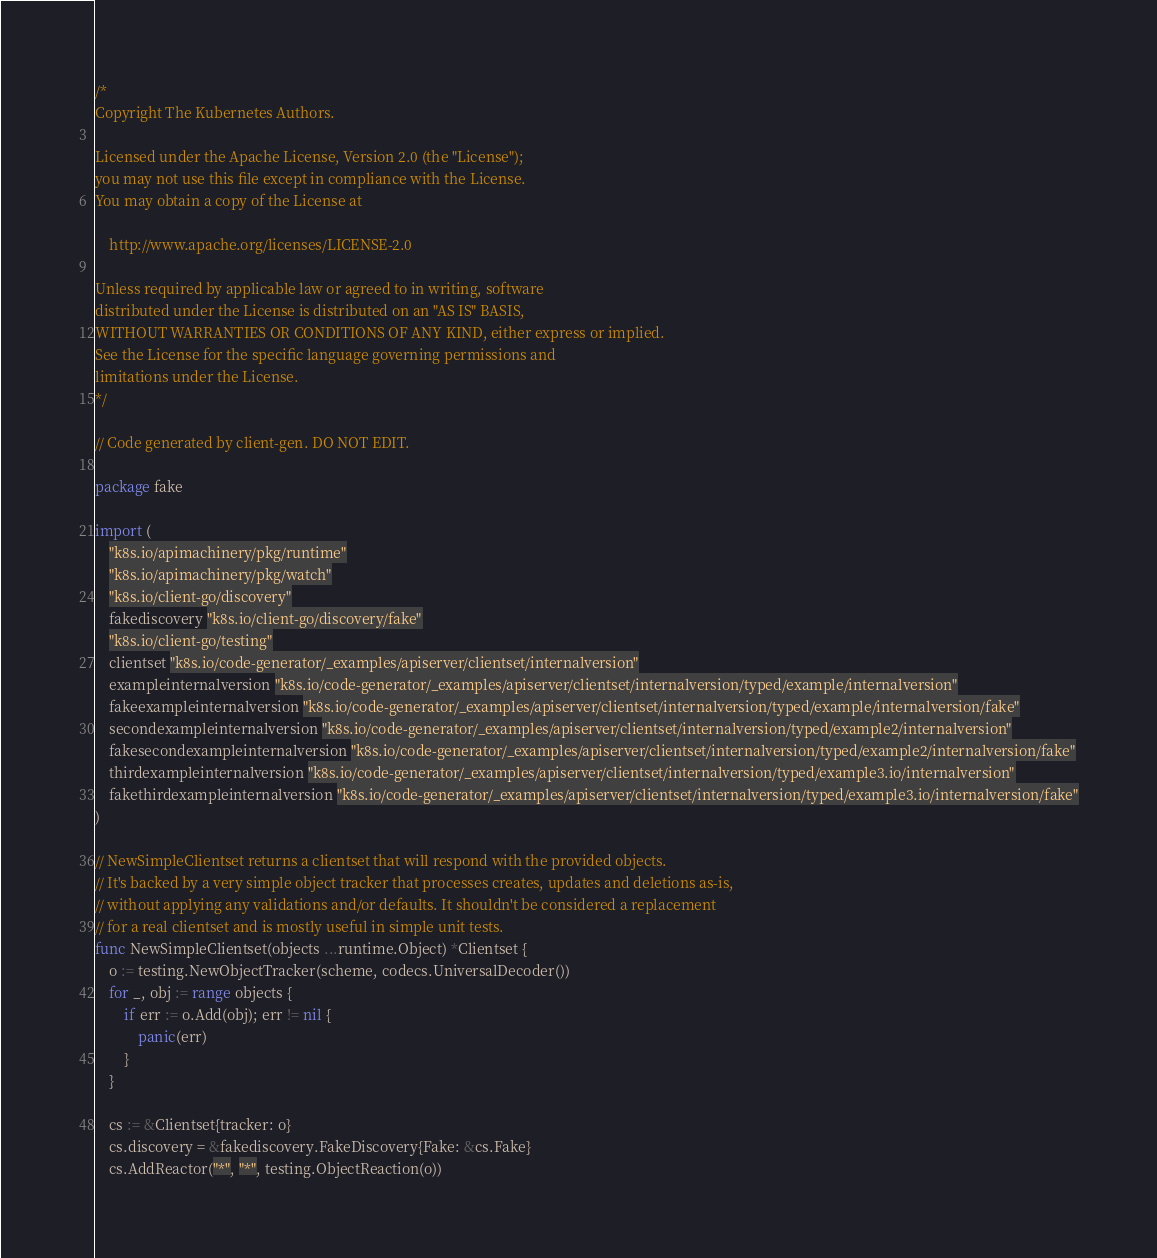Convert code to text. <code><loc_0><loc_0><loc_500><loc_500><_Go_>/*
Copyright The Kubernetes Authors.

Licensed under the Apache License, Version 2.0 (the "License");
you may not use this file except in compliance with the License.
You may obtain a copy of the License at

    http://www.apache.org/licenses/LICENSE-2.0

Unless required by applicable law or agreed to in writing, software
distributed under the License is distributed on an "AS IS" BASIS,
WITHOUT WARRANTIES OR CONDITIONS OF ANY KIND, either express or implied.
See the License for the specific language governing permissions and
limitations under the License.
*/

// Code generated by client-gen. DO NOT EDIT.

package fake

import (
	"k8s.io/apimachinery/pkg/runtime"
	"k8s.io/apimachinery/pkg/watch"
	"k8s.io/client-go/discovery"
	fakediscovery "k8s.io/client-go/discovery/fake"
	"k8s.io/client-go/testing"
	clientset "k8s.io/code-generator/_examples/apiserver/clientset/internalversion"
	exampleinternalversion "k8s.io/code-generator/_examples/apiserver/clientset/internalversion/typed/example/internalversion"
	fakeexampleinternalversion "k8s.io/code-generator/_examples/apiserver/clientset/internalversion/typed/example/internalversion/fake"
	secondexampleinternalversion "k8s.io/code-generator/_examples/apiserver/clientset/internalversion/typed/example2/internalversion"
	fakesecondexampleinternalversion "k8s.io/code-generator/_examples/apiserver/clientset/internalversion/typed/example2/internalversion/fake"
	thirdexampleinternalversion "k8s.io/code-generator/_examples/apiserver/clientset/internalversion/typed/example3.io/internalversion"
	fakethirdexampleinternalversion "k8s.io/code-generator/_examples/apiserver/clientset/internalversion/typed/example3.io/internalversion/fake"
)

// NewSimpleClientset returns a clientset that will respond with the provided objects.
// It's backed by a very simple object tracker that processes creates, updates and deletions as-is,
// without applying any validations and/or defaults. It shouldn't be considered a replacement
// for a real clientset and is mostly useful in simple unit tests.
func NewSimpleClientset(objects ...runtime.Object) *Clientset {
	o := testing.NewObjectTracker(scheme, codecs.UniversalDecoder())
	for _, obj := range objects {
		if err := o.Add(obj); err != nil {
			panic(err)
		}
	}

	cs := &Clientset{tracker: o}
	cs.discovery = &fakediscovery.FakeDiscovery{Fake: &cs.Fake}
	cs.AddReactor("*", "*", testing.ObjectReaction(o))</code> 